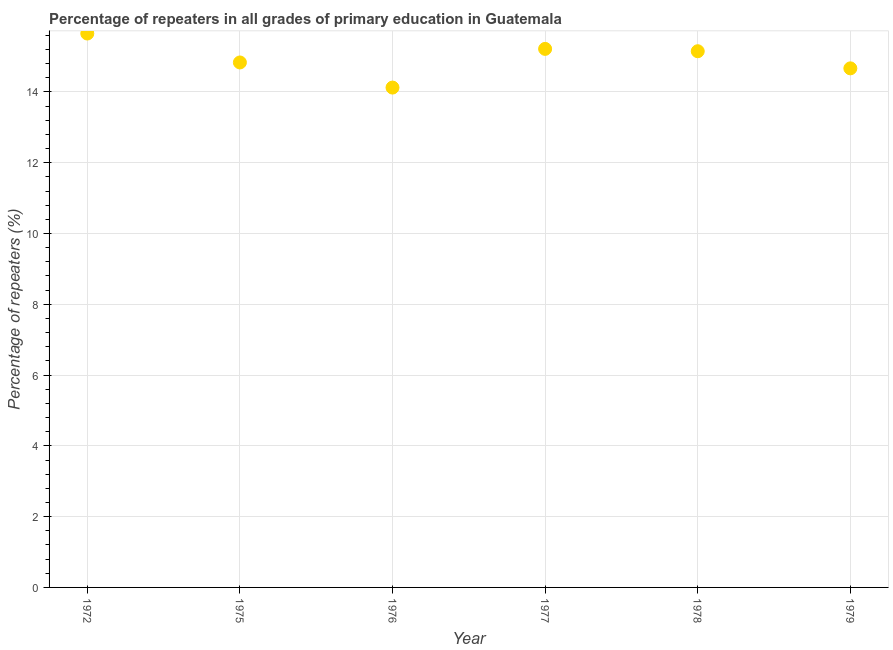What is the percentage of repeaters in primary education in 1979?
Give a very brief answer. 14.67. Across all years, what is the maximum percentage of repeaters in primary education?
Provide a succinct answer. 15.65. Across all years, what is the minimum percentage of repeaters in primary education?
Give a very brief answer. 14.12. In which year was the percentage of repeaters in primary education maximum?
Give a very brief answer. 1972. In which year was the percentage of repeaters in primary education minimum?
Give a very brief answer. 1976. What is the sum of the percentage of repeaters in primary education?
Ensure brevity in your answer.  89.64. What is the difference between the percentage of repeaters in primary education in 1976 and 1977?
Keep it short and to the point. -1.09. What is the average percentage of repeaters in primary education per year?
Provide a short and direct response. 14.94. What is the median percentage of repeaters in primary education?
Keep it short and to the point. 14.99. What is the ratio of the percentage of repeaters in primary education in 1972 to that in 1977?
Keep it short and to the point. 1.03. Is the percentage of repeaters in primary education in 1972 less than that in 1975?
Make the answer very short. No. What is the difference between the highest and the second highest percentage of repeaters in primary education?
Provide a succinct answer. 0.43. What is the difference between the highest and the lowest percentage of repeaters in primary education?
Provide a succinct answer. 1.53. In how many years, is the percentage of repeaters in primary education greater than the average percentage of repeaters in primary education taken over all years?
Make the answer very short. 3. Does the percentage of repeaters in primary education monotonically increase over the years?
Ensure brevity in your answer.  No. How many dotlines are there?
Offer a very short reply. 1. Are the values on the major ticks of Y-axis written in scientific E-notation?
Provide a short and direct response. No. Does the graph contain grids?
Ensure brevity in your answer.  Yes. What is the title of the graph?
Ensure brevity in your answer.  Percentage of repeaters in all grades of primary education in Guatemala. What is the label or title of the X-axis?
Your answer should be very brief. Year. What is the label or title of the Y-axis?
Your answer should be compact. Percentage of repeaters (%). What is the Percentage of repeaters (%) in 1972?
Keep it short and to the point. 15.65. What is the Percentage of repeaters (%) in 1975?
Keep it short and to the point. 14.83. What is the Percentage of repeaters (%) in 1976?
Your answer should be compact. 14.12. What is the Percentage of repeaters (%) in 1977?
Your answer should be compact. 15.22. What is the Percentage of repeaters (%) in 1978?
Your answer should be compact. 15.15. What is the Percentage of repeaters (%) in 1979?
Provide a succinct answer. 14.67. What is the difference between the Percentage of repeaters (%) in 1972 and 1975?
Your response must be concise. 0.82. What is the difference between the Percentage of repeaters (%) in 1972 and 1976?
Offer a terse response. 1.53. What is the difference between the Percentage of repeaters (%) in 1972 and 1977?
Provide a succinct answer. 0.43. What is the difference between the Percentage of repeaters (%) in 1972 and 1978?
Ensure brevity in your answer.  0.5. What is the difference between the Percentage of repeaters (%) in 1972 and 1979?
Make the answer very short. 0.98. What is the difference between the Percentage of repeaters (%) in 1975 and 1976?
Make the answer very short. 0.71. What is the difference between the Percentage of repeaters (%) in 1975 and 1977?
Provide a succinct answer. -0.38. What is the difference between the Percentage of repeaters (%) in 1975 and 1978?
Offer a terse response. -0.32. What is the difference between the Percentage of repeaters (%) in 1975 and 1979?
Provide a succinct answer. 0.17. What is the difference between the Percentage of repeaters (%) in 1976 and 1977?
Your answer should be very brief. -1.09. What is the difference between the Percentage of repeaters (%) in 1976 and 1978?
Your answer should be compact. -1.03. What is the difference between the Percentage of repeaters (%) in 1976 and 1979?
Offer a terse response. -0.54. What is the difference between the Percentage of repeaters (%) in 1977 and 1978?
Your response must be concise. 0.07. What is the difference between the Percentage of repeaters (%) in 1977 and 1979?
Provide a succinct answer. 0.55. What is the difference between the Percentage of repeaters (%) in 1978 and 1979?
Provide a short and direct response. 0.48. What is the ratio of the Percentage of repeaters (%) in 1972 to that in 1975?
Provide a succinct answer. 1.05. What is the ratio of the Percentage of repeaters (%) in 1972 to that in 1976?
Your response must be concise. 1.11. What is the ratio of the Percentage of repeaters (%) in 1972 to that in 1978?
Your response must be concise. 1.03. What is the ratio of the Percentage of repeaters (%) in 1972 to that in 1979?
Offer a very short reply. 1.07. What is the ratio of the Percentage of repeaters (%) in 1975 to that in 1977?
Offer a very short reply. 0.97. What is the ratio of the Percentage of repeaters (%) in 1975 to that in 1979?
Your answer should be compact. 1.01. What is the ratio of the Percentage of repeaters (%) in 1976 to that in 1977?
Ensure brevity in your answer.  0.93. What is the ratio of the Percentage of repeaters (%) in 1976 to that in 1978?
Your answer should be compact. 0.93. What is the ratio of the Percentage of repeaters (%) in 1977 to that in 1978?
Provide a succinct answer. 1. What is the ratio of the Percentage of repeaters (%) in 1977 to that in 1979?
Ensure brevity in your answer.  1.04. What is the ratio of the Percentage of repeaters (%) in 1978 to that in 1979?
Give a very brief answer. 1.03. 